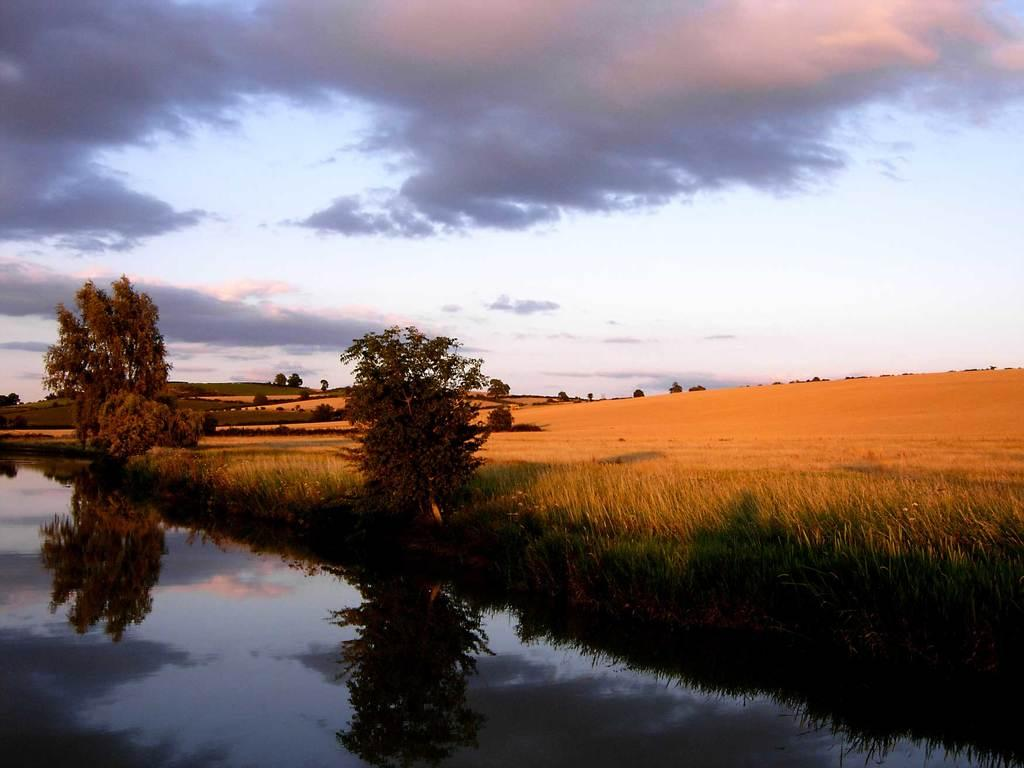What type of natural body of water is visible in the image? There is a lake in the image. What other types of vegetation can be seen in the image? There are plants and trees in the image. What type of ground cover is present in the image? There is grass on the floor in the image. Who is the owner of the can in the image? There is no can present in the image. What type of cushion is on the grass in the image? There is no cushion present in the image. 